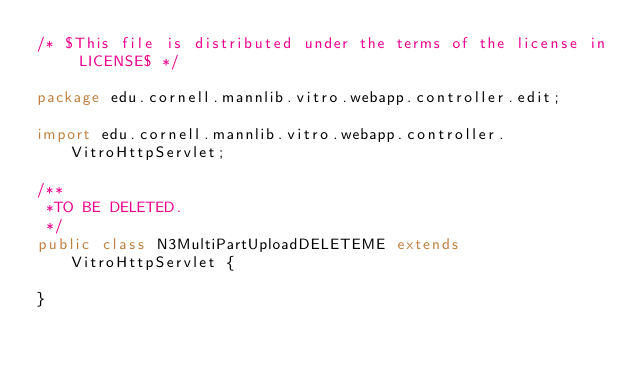<code> <loc_0><loc_0><loc_500><loc_500><_Java_>/* $This file is distributed under the terms of the license in LICENSE$ */

package edu.cornell.mannlib.vitro.webapp.controller.edit;

import edu.cornell.mannlib.vitro.webapp.controller.VitroHttpServlet;

/**
 *TO BE DELETED.
 */
public class N3MultiPartUploadDELETEME extends VitroHttpServlet {
    
}
</code> 